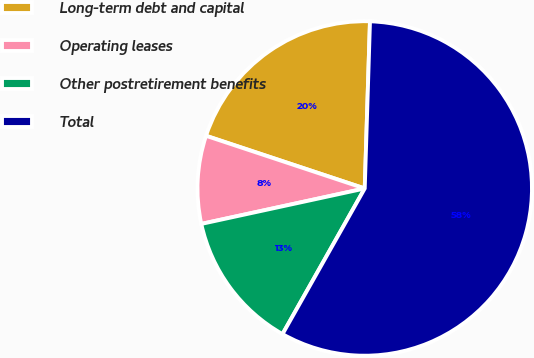Convert chart to OTSL. <chart><loc_0><loc_0><loc_500><loc_500><pie_chart><fcel>Long-term debt and capital<fcel>Operating leases<fcel>Other postretirement benefits<fcel>Total<nl><fcel>20.4%<fcel>8.5%<fcel>13.42%<fcel>57.68%<nl></chart> 